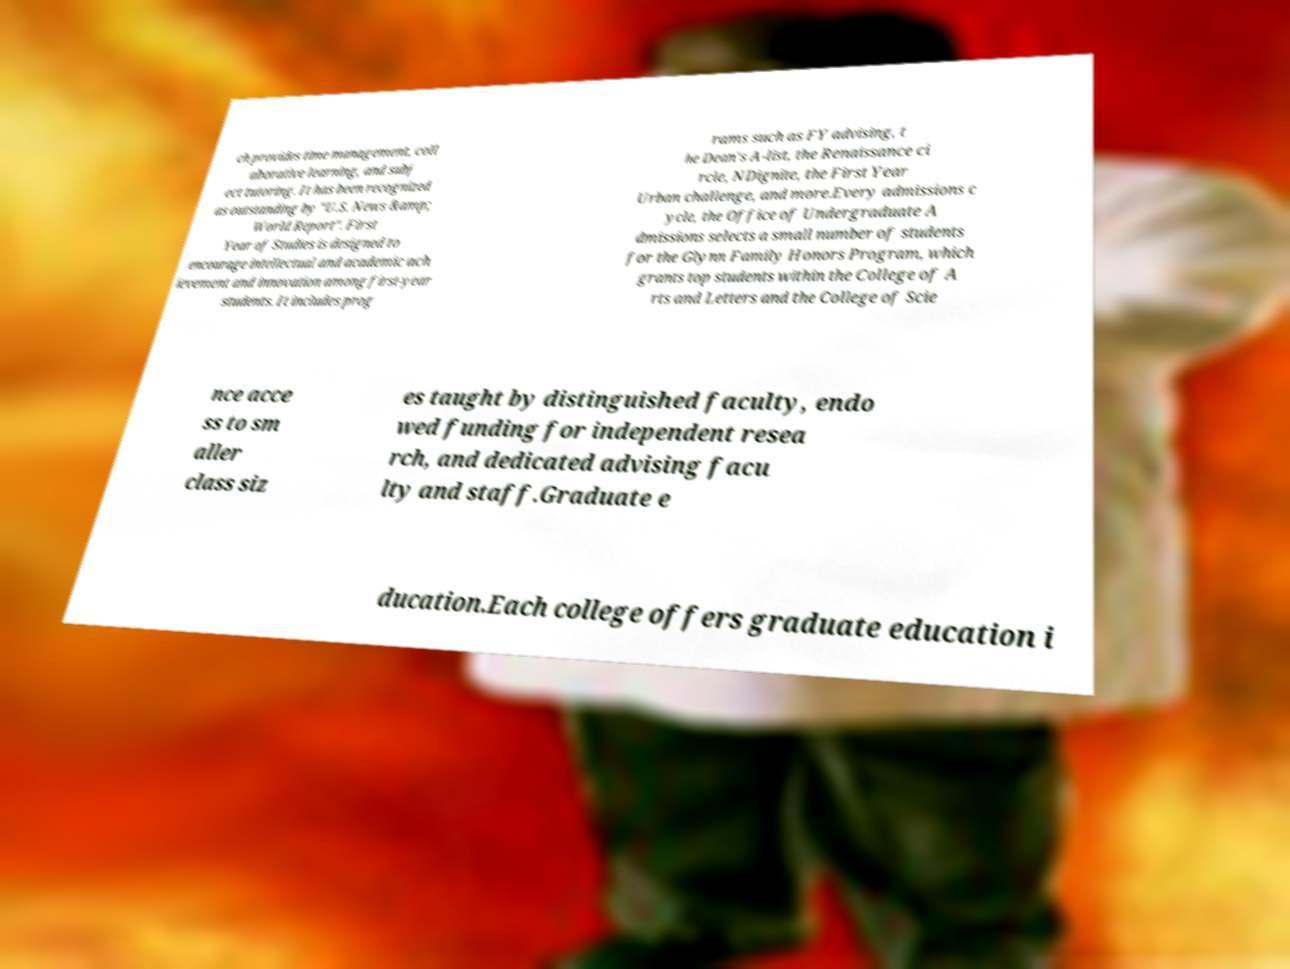Can you accurately transcribe the text from the provided image for me? ch provides time management, coll aborative learning, and subj ect tutoring. It has been recognized as outstanding by "U.S. News &amp; World Report". First Year of Studies is designed to encourage intellectual and academic ach ievement and innovation among first-year students. It includes prog rams such as FY advising, t he Dean's A-list, the Renaissance ci rcle, NDignite, the First Year Urban challenge, and more.Every admissions c ycle, the Office of Undergraduate A dmissions selects a small number of students for the Glynn Family Honors Program, which grants top students within the College of A rts and Letters and the College of Scie nce acce ss to sm aller class siz es taught by distinguished faculty, endo wed funding for independent resea rch, and dedicated advising facu lty and staff.Graduate e ducation.Each college offers graduate education i 